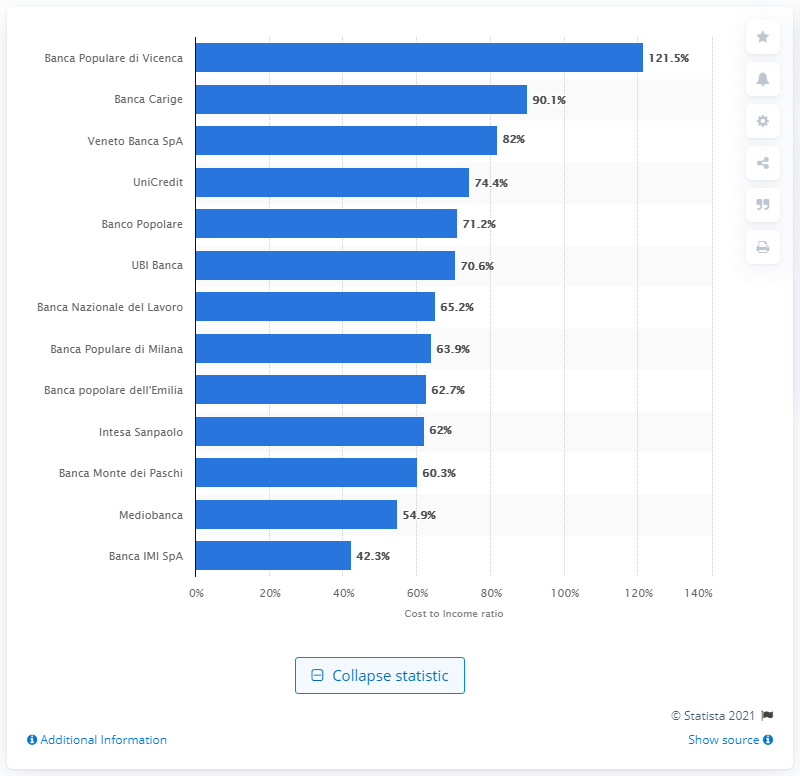Give some essential details in this illustration. The cost-to-income ratio of Banca IMI SpA as of 2016 was 42.3%. Banca Carige's cost to income ratio was 90.1% in the given financial year. The cost to income ratio of Banca Populare di Vicenza was 121.5% in the given year. In 2016, Banca Populare di Vicenza had the highest cost to income ratio among Italian banks. 